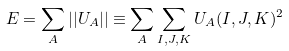Convert formula to latex. <formula><loc_0><loc_0><loc_500><loc_500>E = \sum _ { A } | | U _ { A } | | \equiv \sum _ { A } \sum _ { I , J , K } U _ { A } ( I , J , K ) ^ { 2 }</formula> 